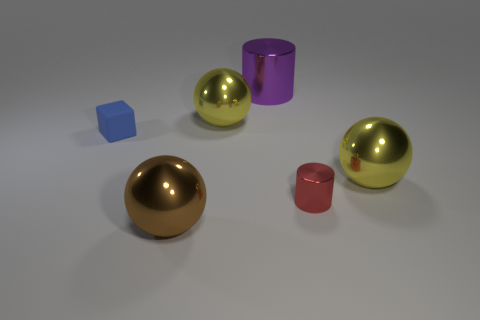Which objects in the image share the same shape? The two gold spheres share the same shape as they're both large and spherical. The red and purple cylinders also share the same shape, albeit different sizes and colors. 